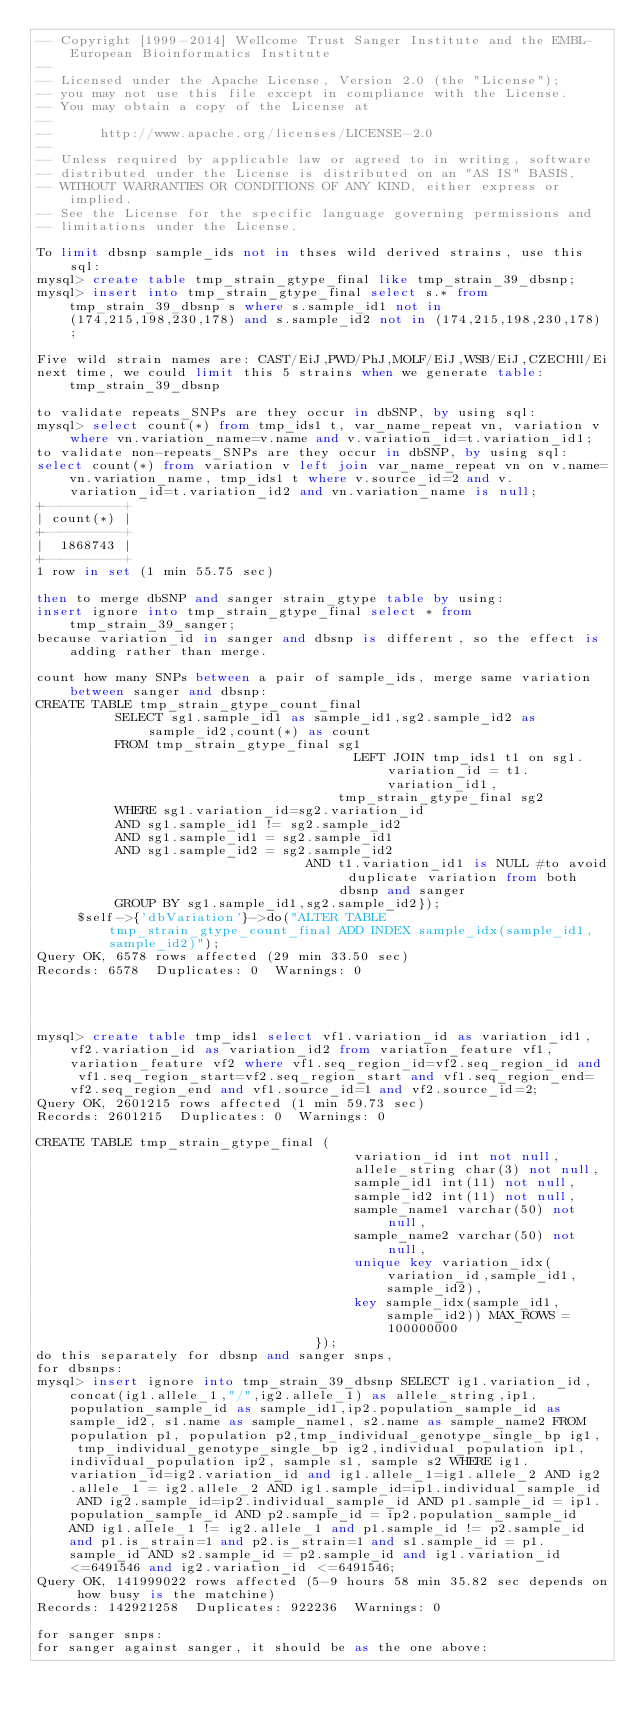<code> <loc_0><loc_0><loc_500><loc_500><_SQL_>-- Copyright [1999-2014] Wellcome Trust Sanger Institute and the EMBL-European Bioinformatics Institute
-- 
-- Licensed under the Apache License, Version 2.0 (the "License");
-- you may not use this file except in compliance with the License.
-- You may obtain a copy of the License at
-- 
--      http://www.apache.org/licenses/LICENSE-2.0
-- 
-- Unless required by applicable law or agreed to in writing, software
-- distributed under the License is distributed on an "AS IS" BASIS,
-- WITHOUT WARRANTIES OR CONDITIONS OF ANY KIND, either express or implied.
-- See the License for the specific language governing permissions and
-- limitations under the License.

To limit dbsnp sample_ids not in thses wild derived strains, use this sql:
mysql> create table tmp_strain_gtype_final like tmp_strain_39_dbsnp;
mysql> insert into tmp_strain_gtype_final select s.* from tmp_strain_39_dbsnp s where s.sample_id1 not in (174,215,198,230,178) and s.sample_id2 not in (174,215,198,230,178);

Five wild strain names are: CAST/EiJ,PWD/PhJ,MOLF/EiJ,WSB/EiJ,CZECHll/Ei
next time, we could limit this 5 strains when we generate table:tmp_strain_39_dbsnp

to validate repeats_SNPs are they occur in dbSNP, by using sql:
mysql> select count(*) from tmp_ids1 t, var_name_repeat vn, variation v where vn.variation_name=v.name and v.variation_id=t.variation_id1;
to validate non-repeats_SNPs are they occur in dbSNP, by using sql:
select count(*) from variation v left join var_name_repeat vn on v.name=vn.variation_name, tmp_ids1 t where v.source_id=2 and v.variation_id=t.variation_id2 and vn.variation_name is null;
+----------+
| count(*) |
+----------+
|  1868743 |
+----------+
1 row in set (1 min 55.75 sec)

then to merge dbSNP and sanger strain_gtype table by using:
insert ignore into tmp_strain_gtype_final select * from tmp_strain_39_sanger;
because variation_id in sanger and dbsnp is different, so the effect is adding rather than merge.

count how many SNPs between a pair of sample_ids, merge same variation between sanger and dbsnp:
CREATE TABLE tmp_strain_gtype_count_final 
 				  SELECT sg1.sample_id1 as sample_id1,sg2.sample_id2 as sample_id2,count(*) as count 
 				  FROM tmp_strain_gtype_final sg1 
                                        LEFT JOIN tmp_ids1 t1 on sg1.variation_id = t1.variation_id1,  
                                      tmp_strain_gtype_final sg2
 				  WHERE sg1.variation_id=sg2.variation_id 
 				  AND sg1.sample_id1 != sg2.sample_id2 
 				  AND sg1.sample_id1 = sg2.sample_id1 
 				  AND sg1.sample_id2 = sg2.sample_id2 
                                  AND t1.variation_id1 is NULL #to avoid duplicate variation from both dbsnp and sanger
 				  GROUP BY sg1.sample_id1,sg2.sample_id2});
     $self->{'dbVariation'}->do("ALTER TABLE tmp_strain_gtype_count_final ADD INDEX sample_idx(sample_id1,sample_id2)");
Query OK, 6578 rows affected (29 min 33.50 sec)
Records: 6578  Duplicates: 0  Warnings: 0




mysql> create table tmp_ids1 select vf1.variation_id as variation_id1, vf2.variation_id as variation_id2 from variation_feature vf1, variation_feature vf2 where vf1.seq_region_id=vf2.seq_region_id and vf1.seq_region_start=vf2.seq_region_start and vf1.seq_region_end=vf2.seq_region_end and vf1.source_id=1 and vf2.source_id=2;
Query OK, 2601215 rows affected (1 min 59.73 sec)
Records: 2601215  Duplicates: 0  Warnings: 0

CREATE TABLE tmp_strain_gtype_final (
                                        variation_id int not null,
                                        allele_string char(3) not null,
                                        sample_id1 int(11) not null,
                                        sample_id2 int(11) not null,
                                        sample_name1 varchar(50) not null,
                                        sample_name2 varchar(50) not null,
                                        unique key variation_idx(variation_id,sample_id1,sample_id2),
                                        key sample_idx(sample_id1,sample_id2)) MAX_ROWS = 100000000
                                   });
do this separately for dbsnp and sanger snps, 
for dbsnps:
mysql> insert ignore into tmp_strain_39_dbsnp SELECT ig1.variation_id,concat(ig1.allele_1,"/",ig2.allele_1) as allele_string,ip1.population_sample_id as sample_id1,ip2.population_sample_id as sample_id2, s1.name as sample_name1, s2.name as sample_name2 FROM population p1, population p2,tmp_individual_genotype_single_bp ig1, tmp_individual_genotype_single_bp ig2,individual_population ip1,individual_population ip2, sample s1, sample s2 WHERE ig1.variation_id=ig2.variation_id and ig1.allele_1=ig1.allele_2 AND ig2.allele_1 = ig2.allele_2 AND ig1.sample_id=ip1.individual_sample_id AND ig2.sample_id=ip2.individual_sample_id AND p1.sample_id = ip1.population_sample_id AND p2.sample_id = ip2.population_sample_id AND ig1.allele_1 != ig2.allele_1 and p1.sample_id != p2.sample_id and p1.is_strain=1 and p2.is_strain=1 and s1.sample_id = p1.sample_id AND s2.sample_id = p2.sample_id and ig1.variation_id <=6491546 and ig2.variation_id <=6491546;
Query OK, 141999022 rows affected (5-9 hours 58 min 35.82 sec depends on how busy is the matchine)
Records: 142921258  Duplicates: 922236  Warnings: 0

for sanger snps:
for sanger against sanger, it should be as the one above:</code> 